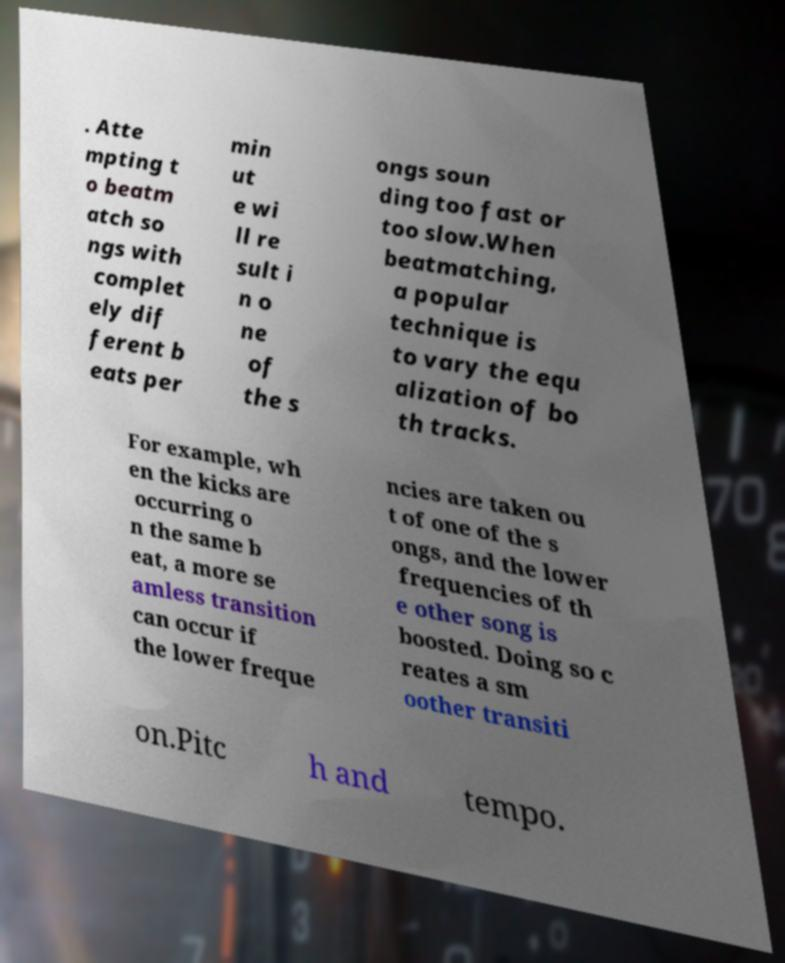I need the written content from this picture converted into text. Can you do that? . Atte mpting t o beatm atch so ngs with complet ely dif ferent b eats per min ut e wi ll re sult i n o ne of the s ongs soun ding too fast or too slow.When beatmatching, a popular technique is to vary the equ alization of bo th tracks. For example, wh en the kicks are occurring o n the same b eat, a more se amless transition can occur if the lower freque ncies are taken ou t of one of the s ongs, and the lower frequencies of th e other song is boosted. Doing so c reates a sm oother transiti on.Pitc h and tempo. 